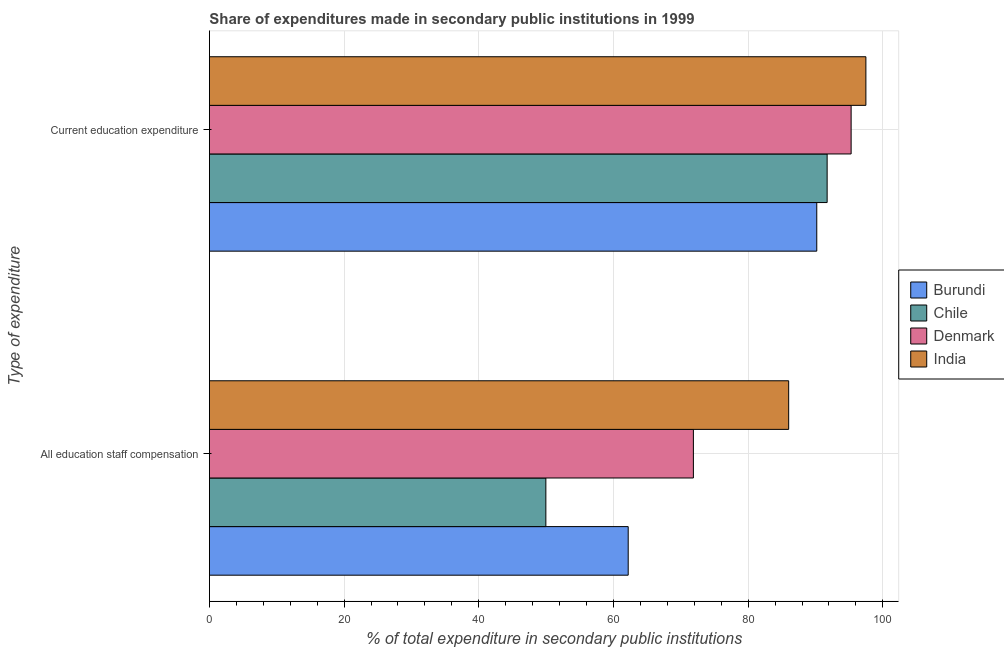Are the number of bars per tick equal to the number of legend labels?
Your answer should be very brief. Yes. How many bars are there on the 1st tick from the top?
Your answer should be very brief. 4. What is the label of the 1st group of bars from the top?
Your answer should be compact. Current education expenditure. What is the expenditure in education in Burundi?
Offer a very short reply. 90.19. Across all countries, what is the maximum expenditure in education?
Make the answer very short. 97.49. Across all countries, what is the minimum expenditure in education?
Offer a very short reply. 90.19. What is the total expenditure in staff compensation in the graph?
Offer a very short reply. 270.05. What is the difference between the expenditure in staff compensation in Denmark and that in India?
Your answer should be compact. -14.15. What is the difference between the expenditure in education in Denmark and the expenditure in staff compensation in Chile?
Your answer should be very brief. 45.33. What is the average expenditure in education per country?
Offer a very short reply. 93.68. What is the difference between the expenditure in staff compensation and expenditure in education in Chile?
Ensure brevity in your answer.  -41.77. In how many countries, is the expenditure in education greater than 80 %?
Give a very brief answer. 4. What is the ratio of the expenditure in staff compensation in India to that in Denmark?
Ensure brevity in your answer.  1.2. In how many countries, is the expenditure in education greater than the average expenditure in education taken over all countries?
Your answer should be very brief. 2. What does the 4th bar from the top in All education staff compensation represents?
Your response must be concise. Burundi. What does the 2nd bar from the bottom in All education staff compensation represents?
Your response must be concise. Chile. Are the values on the major ticks of X-axis written in scientific E-notation?
Ensure brevity in your answer.  No. Where does the legend appear in the graph?
Make the answer very short. Center right. How many legend labels are there?
Give a very brief answer. 4. How are the legend labels stacked?
Offer a terse response. Vertical. What is the title of the graph?
Your response must be concise. Share of expenditures made in secondary public institutions in 1999. What is the label or title of the X-axis?
Offer a very short reply. % of total expenditure in secondary public institutions. What is the label or title of the Y-axis?
Make the answer very short. Type of expenditure. What is the % of total expenditure in secondary public institutions in Burundi in All education staff compensation?
Your answer should be compact. 62.19. What is the % of total expenditure in secondary public institutions in Chile in All education staff compensation?
Keep it short and to the point. 49.96. What is the % of total expenditure in secondary public institutions in Denmark in All education staff compensation?
Your answer should be very brief. 71.87. What is the % of total expenditure in secondary public institutions of India in All education staff compensation?
Give a very brief answer. 86.02. What is the % of total expenditure in secondary public institutions in Burundi in Current education expenditure?
Provide a succinct answer. 90.19. What is the % of total expenditure in secondary public institutions of Chile in Current education expenditure?
Provide a succinct answer. 91.73. What is the % of total expenditure in secondary public institutions in Denmark in Current education expenditure?
Offer a terse response. 95.3. What is the % of total expenditure in secondary public institutions of India in Current education expenditure?
Your answer should be very brief. 97.49. Across all Type of expenditure, what is the maximum % of total expenditure in secondary public institutions in Burundi?
Your answer should be compact. 90.19. Across all Type of expenditure, what is the maximum % of total expenditure in secondary public institutions in Chile?
Provide a succinct answer. 91.73. Across all Type of expenditure, what is the maximum % of total expenditure in secondary public institutions in Denmark?
Offer a very short reply. 95.3. Across all Type of expenditure, what is the maximum % of total expenditure in secondary public institutions of India?
Give a very brief answer. 97.49. Across all Type of expenditure, what is the minimum % of total expenditure in secondary public institutions in Burundi?
Your response must be concise. 62.19. Across all Type of expenditure, what is the minimum % of total expenditure in secondary public institutions of Chile?
Offer a very short reply. 49.96. Across all Type of expenditure, what is the minimum % of total expenditure in secondary public institutions in Denmark?
Your response must be concise. 71.87. Across all Type of expenditure, what is the minimum % of total expenditure in secondary public institutions of India?
Ensure brevity in your answer.  86.02. What is the total % of total expenditure in secondary public institutions in Burundi in the graph?
Offer a very short reply. 152.38. What is the total % of total expenditure in secondary public institutions of Chile in the graph?
Provide a short and direct response. 141.7. What is the total % of total expenditure in secondary public institutions of Denmark in the graph?
Offer a terse response. 167.17. What is the total % of total expenditure in secondary public institutions of India in the graph?
Your response must be concise. 183.51. What is the difference between the % of total expenditure in secondary public institutions of Burundi in All education staff compensation and that in Current education expenditure?
Your answer should be compact. -28. What is the difference between the % of total expenditure in secondary public institutions in Chile in All education staff compensation and that in Current education expenditure?
Offer a very short reply. -41.77. What is the difference between the % of total expenditure in secondary public institutions of Denmark in All education staff compensation and that in Current education expenditure?
Give a very brief answer. -23.42. What is the difference between the % of total expenditure in secondary public institutions of India in All education staff compensation and that in Current education expenditure?
Keep it short and to the point. -11.47. What is the difference between the % of total expenditure in secondary public institutions of Burundi in All education staff compensation and the % of total expenditure in secondary public institutions of Chile in Current education expenditure?
Your response must be concise. -29.54. What is the difference between the % of total expenditure in secondary public institutions in Burundi in All education staff compensation and the % of total expenditure in secondary public institutions in Denmark in Current education expenditure?
Your answer should be compact. -33.11. What is the difference between the % of total expenditure in secondary public institutions in Burundi in All education staff compensation and the % of total expenditure in secondary public institutions in India in Current education expenditure?
Offer a very short reply. -35.3. What is the difference between the % of total expenditure in secondary public institutions of Chile in All education staff compensation and the % of total expenditure in secondary public institutions of Denmark in Current education expenditure?
Keep it short and to the point. -45.33. What is the difference between the % of total expenditure in secondary public institutions of Chile in All education staff compensation and the % of total expenditure in secondary public institutions of India in Current education expenditure?
Give a very brief answer. -47.53. What is the difference between the % of total expenditure in secondary public institutions of Denmark in All education staff compensation and the % of total expenditure in secondary public institutions of India in Current education expenditure?
Your response must be concise. -25.62. What is the average % of total expenditure in secondary public institutions of Burundi per Type of expenditure?
Give a very brief answer. 76.19. What is the average % of total expenditure in secondary public institutions in Chile per Type of expenditure?
Your response must be concise. 70.85. What is the average % of total expenditure in secondary public institutions of Denmark per Type of expenditure?
Your answer should be very brief. 83.58. What is the average % of total expenditure in secondary public institutions in India per Type of expenditure?
Ensure brevity in your answer.  91.75. What is the difference between the % of total expenditure in secondary public institutions of Burundi and % of total expenditure in secondary public institutions of Chile in All education staff compensation?
Provide a succinct answer. 12.23. What is the difference between the % of total expenditure in secondary public institutions of Burundi and % of total expenditure in secondary public institutions of Denmark in All education staff compensation?
Your response must be concise. -9.68. What is the difference between the % of total expenditure in secondary public institutions of Burundi and % of total expenditure in secondary public institutions of India in All education staff compensation?
Make the answer very short. -23.83. What is the difference between the % of total expenditure in secondary public institutions of Chile and % of total expenditure in secondary public institutions of Denmark in All education staff compensation?
Ensure brevity in your answer.  -21.91. What is the difference between the % of total expenditure in secondary public institutions in Chile and % of total expenditure in secondary public institutions in India in All education staff compensation?
Your answer should be very brief. -36.06. What is the difference between the % of total expenditure in secondary public institutions of Denmark and % of total expenditure in secondary public institutions of India in All education staff compensation?
Keep it short and to the point. -14.15. What is the difference between the % of total expenditure in secondary public institutions in Burundi and % of total expenditure in secondary public institutions in Chile in Current education expenditure?
Provide a succinct answer. -1.54. What is the difference between the % of total expenditure in secondary public institutions of Burundi and % of total expenditure in secondary public institutions of Denmark in Current education expenditure?
Give a very brief answer. -5.1. What is the difference between the % of total expenditure in secondary public institutions in Burundi and % of total expenditure in secondary public institutions in India in Current education expenditure?
Offer a terse response. -7.3. What is the difference between the % of total expenditure in secondary public institutions in Chile and % of total expenditure in secondary public institutions in Denmark in Current education expenditure?
Offer a terse response. -3.56. What is the difference between the % of total expenditure in secondary public institutions in Chile and % of total expenditure in secondary public institutions in India in Current education expenditure?
Ensure brevity in your answer.  -5.75. What is the difference between the % of total expenditure in secondary public institutions of Denmark and % of total expenditure in secondary public institutions of India in Current education expenditure?
Provide a short and direct response. -2.19. What is the ratio of the % of total expenditure in secondary public institutions in Burundi in All education staff compensation to that in Current education expenditure?
Your response must be concise. 0.69. What is the ratio of the % of total expenditure in secondary public institutions in Chile in All education staff compensation to that in Current education expenditure?
Provide a succinct answer. 0.54. What is the ratio of the % of total expenditure in secondary public institutions of Denmark in All education staff compensation to that in Current education expenditure?
Offer a very short reply. 0.75. What is the ratio of the % of total expenditure in secondary public institutions of India in All education staff compensation to that in Current education expenditure?
Your answer should be compact. 0.88. What is the difference between the highest and the second highest % of total expenditure in secondary public institutions of Burundi?
Your answer should be compact. 28. What is the difference between the highest and the second highest % of total expenditure in secondary public institutions in Chile?
Ensure brevity in your answer.  41.77. What is the difference between the highest and the second highest % of total expenditure in secondary public institutions in Denmark?
Provide a short and direct response. 23.42. What is the difference between the highest and the second highest % of total expenditure in secondary public institutions of India?
Keep it short and to the point. 11.47. What is the difference between the highest and the lowest % of total expenditure in secondary public institutions in Burundi?
Make the answer very short. 28. What is the difference between the highest and the lowest % of total expenditure in secondary public institutions of Chile?
Ensure brevity in your answer.  41.77. What is the difference between the highest and the lowest % of total expenditure in secondary public institutions in Denmark?
Ensure brevity in your answer.  23.42. What is the difference between the highest and the lowest % of total expenditure in secondary public institutions of India?
Offer a terse response. 11.47. 